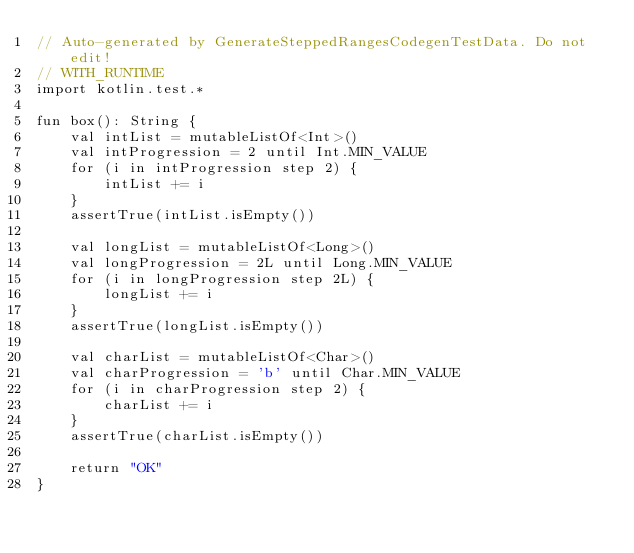<code> <loc_0><loc_0><loc_500><loc_500><_Kotlin_>// Auto-generated by GenerateSteppedRangesCodegenTestData. Do not edit!
// WITH_RUNTIME
import kotlin.test.*

fun box(): String {
    val intList = mutableListOf<Int>()
    val intProgression = 2 until Int.MIN_VALUE
    for (i in intProgression step 2) {
        intList += i
    }
    assertTrue(intList.isEmpty())

    val longList = mutableListOf<Long>()
    val longProgression = 2L until Long.MIN_VALUE
    for (i in longProgression step 2L) {
        longList += i
    }
    assertTrue(longList.isEmpty())

    val charList = mutableListOf<Char>()
    val charProgression = 'b' until Char.MIN_VALUE
    for (i in charProgression step 2) {
        charList += i
    }
    assertTrue(charList.isEmpty())

    return "OK"
}</code> 